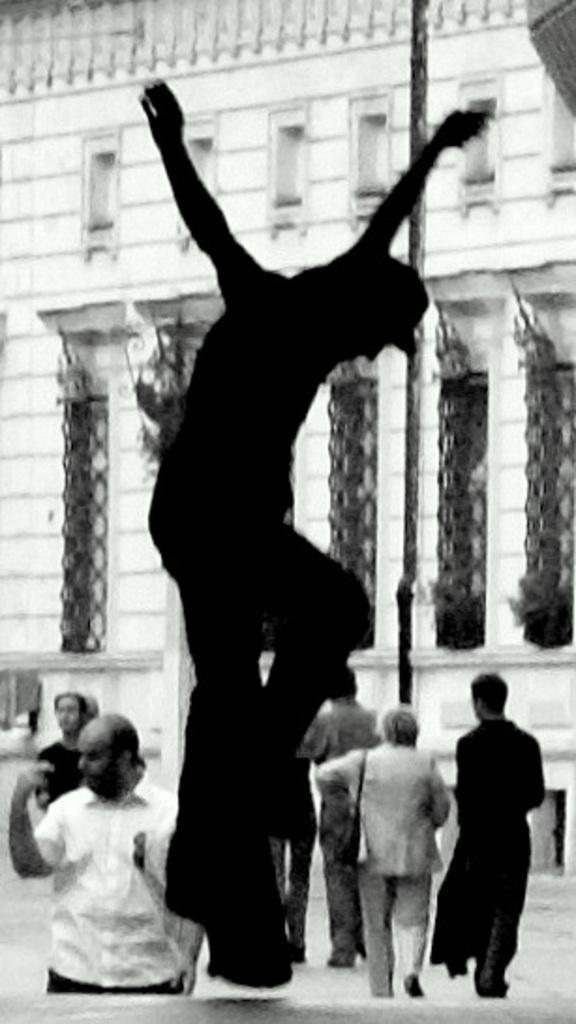Describe this image in one or two sentences. It is a black and white picture. In this image we can see people, pole and building. 